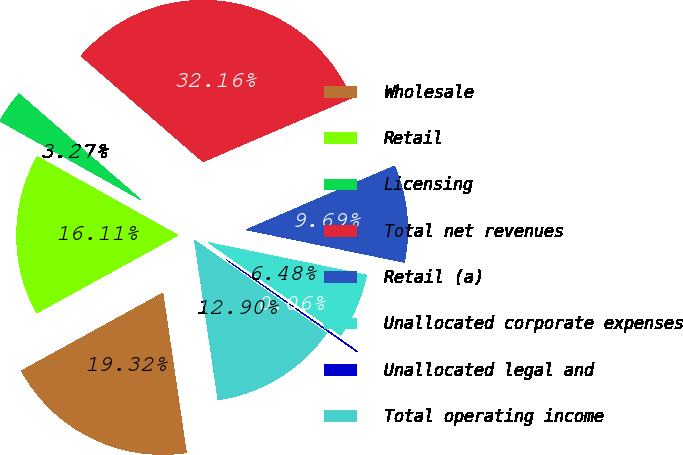Convert chart to OTSL. <chart><loc_0><loc_0><loc_500><loc_500><pie_chart><fcel>Wholesale<fcel>Retail<fcel>Licensing<fcel>Total net revenues<fcel>Retail (a)<fcel>Unallocated corporate expenses<fcel>Unallocated legal and<fcel>Total operating income<nl><fcel>19.32%<fcel>16.11%<fcel>3.27%<fcel>32.16%<fcel>9.69%<fcel>6.48%<fcel>0.06%<fcel>12.9%<nl></chart> 